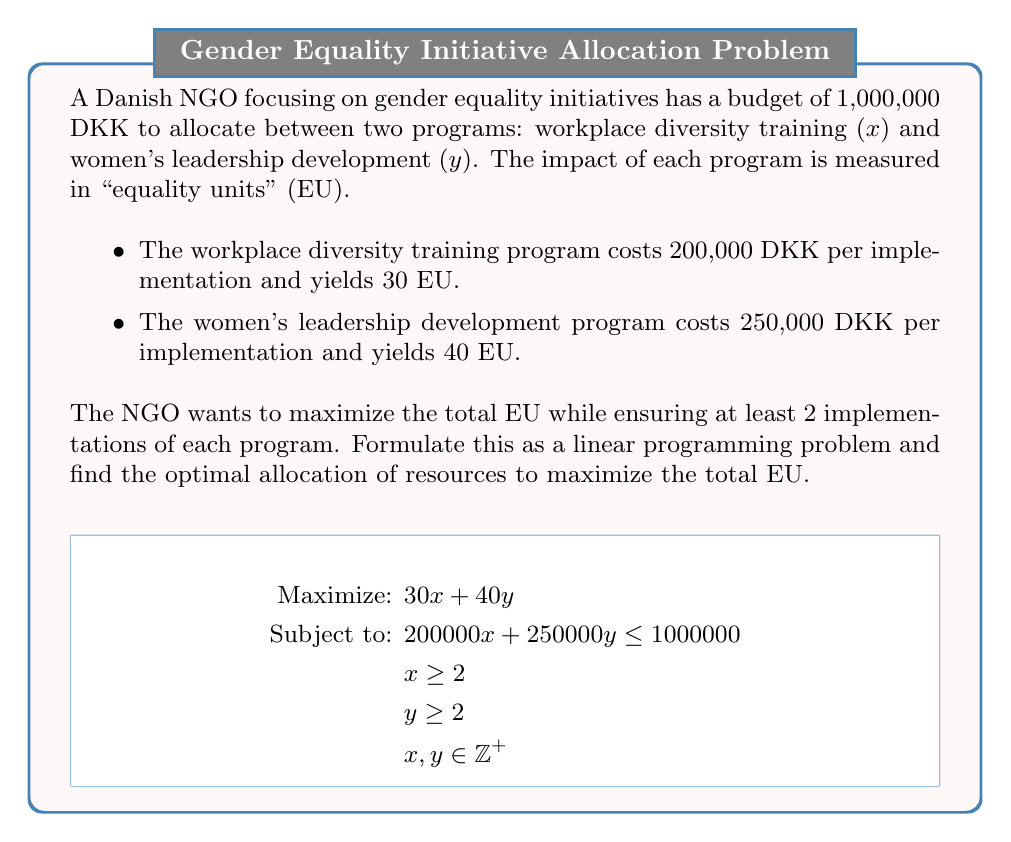What is the answer to this math problem? To solve this linear programming problem, we'll follow these steps:

1) First, let's identify the constraints:
   $$200000x + 250000y \leq 1000000$$ (budget constraint)
   $$x \geq 2$$ and $$y \geq 2$$ (minimum implementations)
   $$x, y \in \mathbb{Z}^+$$ (integer constraint)

2) Simplify the budget constraint:
   $$4x + 5y \leq 20$$

3) Plot the feasible region:
   [asy]
   import geometry;
   
   size(200);
   
   real[] xticks={0,2,4,6,8,10};
   real[] yticks={0,2,4,6,8,10};
   
   xaxis("x",0,10,Arrow);
   yaxis("y",0,10,Arrow);
   
   for(int i=0; i<xticks.length; ++i) {
     draw((xticks[i],0)--(xticks[i],-0.1),black);
     label(string(xticks[i]),(xticks[i],-0.5),black);
   }
   
   for(int i=0; i<yticks.length; ++i) {
     draw((0,yticks[i])--(-0.1,yticks[i]),black);
     label(string(yticks[i]),(-0.5,yticks[i]),black);
   }
   
   path budget = (5,0)--(0,4);
   draw(budget,red);
   
   fill((2,2)--(5,2)--(3,4)--(2,4)--cycle,paleblue);
   
   draw((2,0)--(2,10),dashed);
   draw((0,2)--(10,2),dashed);
   
   label("Feasible Region",(!.8,1.8),NE);
   [/asy]

4) The corner points of the feasible region are (2,2), (5,2), and (3,4).

5) Evaluate the objective function at these points:
   At (2,2): 30(2) + 40(2) = 140 EU
   At (5,2): 30(5) + 40(2) = 230 EU
   At (3,4): 30(3) + 40(4) = 250 EU

6) The maximum value is achieved at the point (3,4).

Therefore, the optimal allocation is to implement the workplace diversity training program 3 times and the women's leadership development program 4 times, resulting in a total of 250 equality units.
Answer: 3 workplace diversity trainings, 4 women's leadership developments; 250 EU 